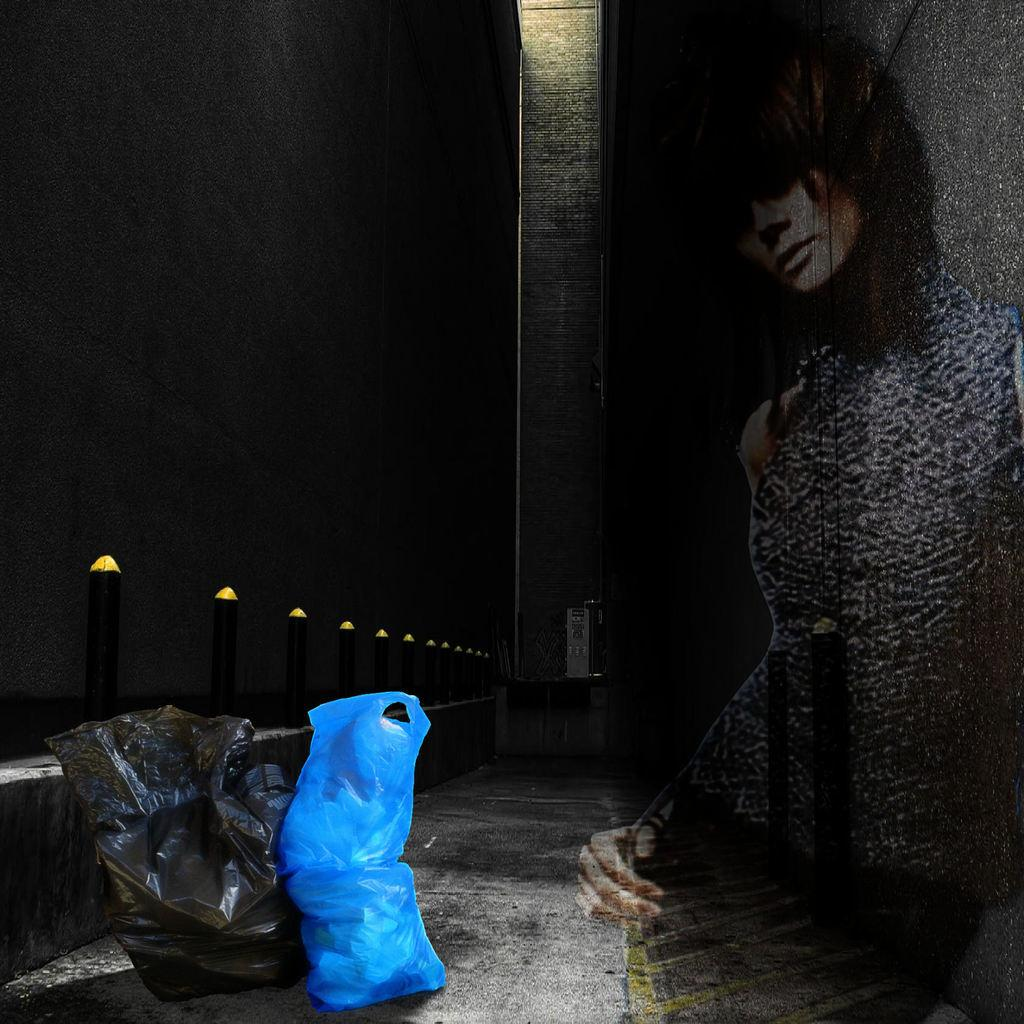What objects are on the ground in the image? There are two packets on the ground in the image. What can be seen on the wall in the image? There are light poles on the wall in the image. Where is the woman located in the image? The woman is on the right side of the image. What is visible in the background of the image? There is a pillar in the background of the image. What type of patch is the woman sewing onto her shirt in the image? There is no patch or sewing activity visible in the image; the woman is simply standing on the right side. 